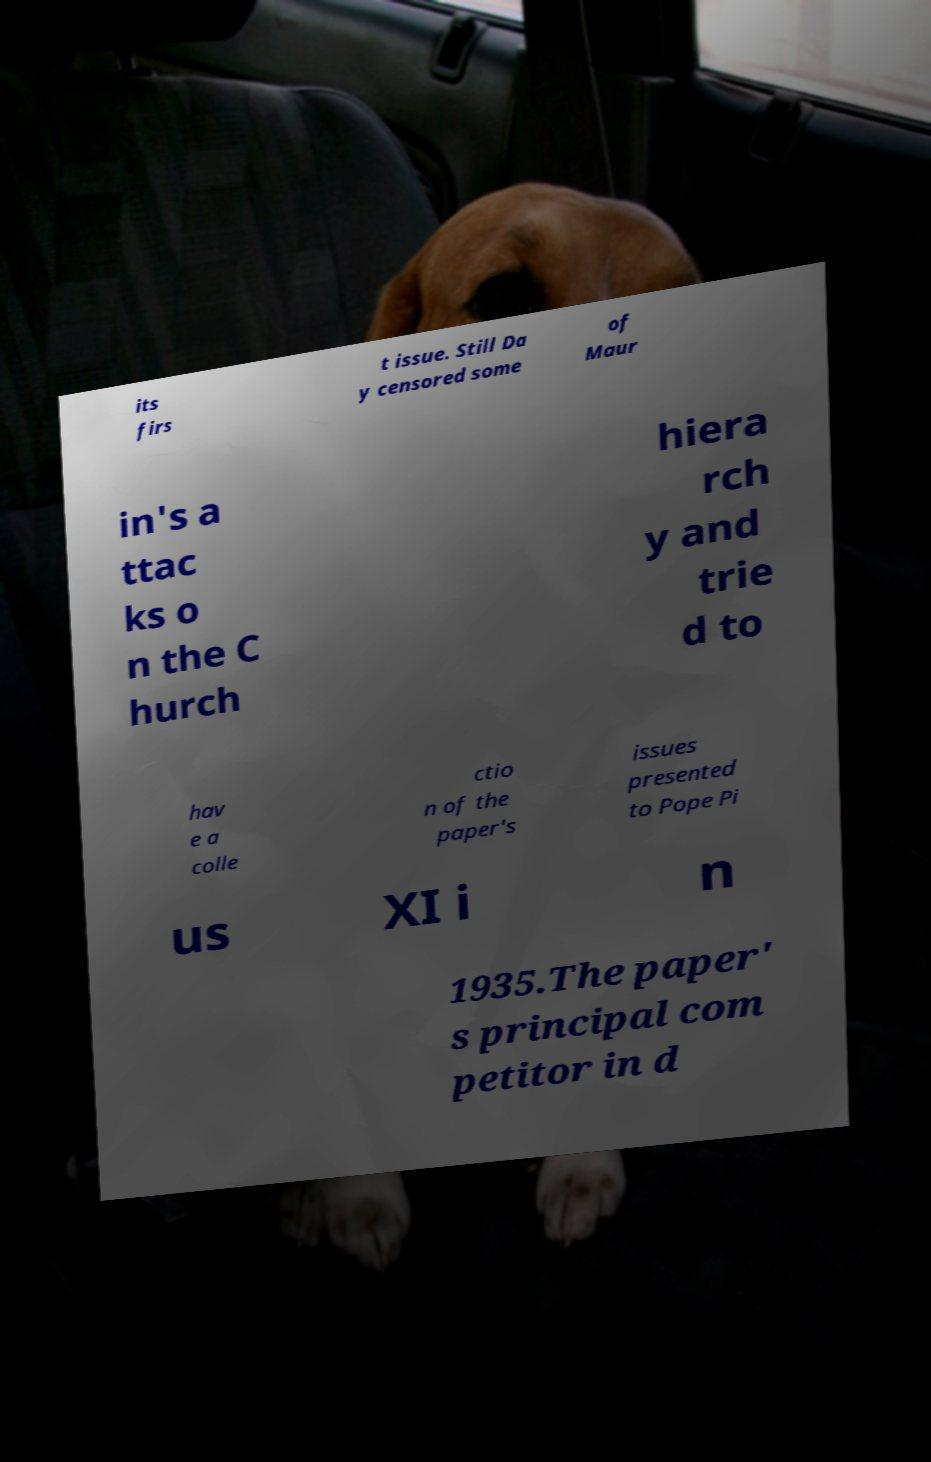I need the written content from this picture converted into text. Can you do that? its firs t issue. Still Da y censored some of Maur in's a ttac ks o n the C hurch hiera rch y and trie d to hav e a colle ctio n of the paper's issues presented to Pope Pi us XI i n 1935.The paper' s principal com petitor in d 